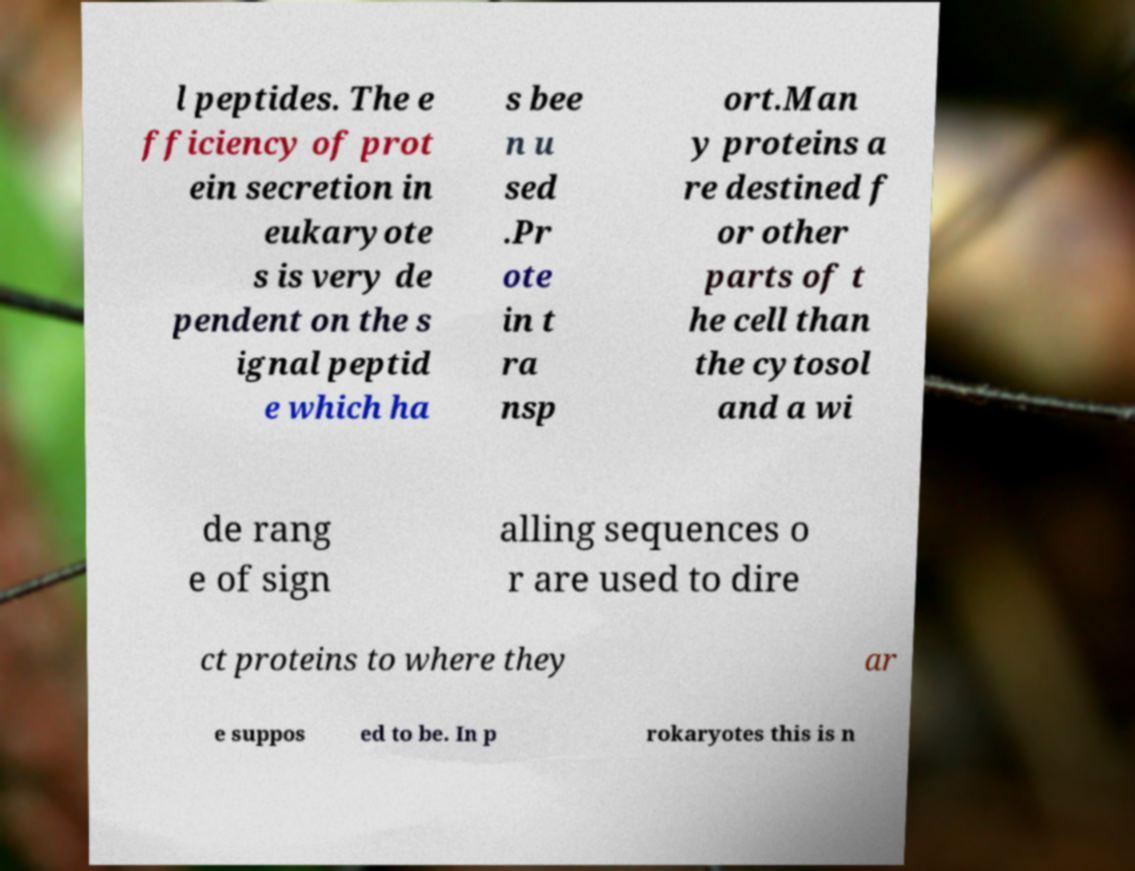Please identify and transcribe the text found in this image. l peptides. The e fficiency of prot ein secretion in eukaryote s is very de pendent on the s ignal peptid e which ha s bee n u sed .Pr ote in t ra nsp ort.Man y proteins a re destined f or other parts of t he cell than the cytosol and a wi de rang e of sign alling sequences o r are used to dire ct proteins to where they ar e suppos ed to be. In p rokaryotes this is n 